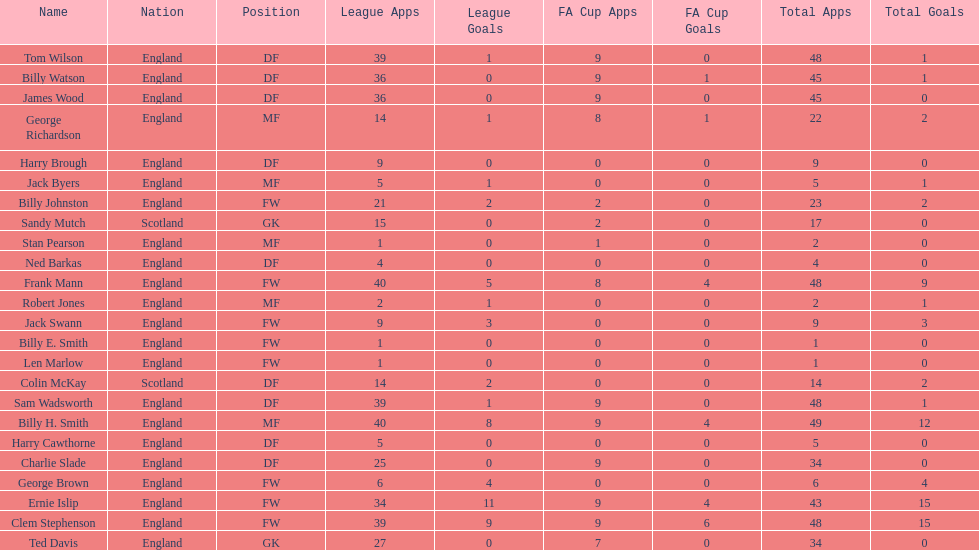What is the first name listed? Ned Barkas. 